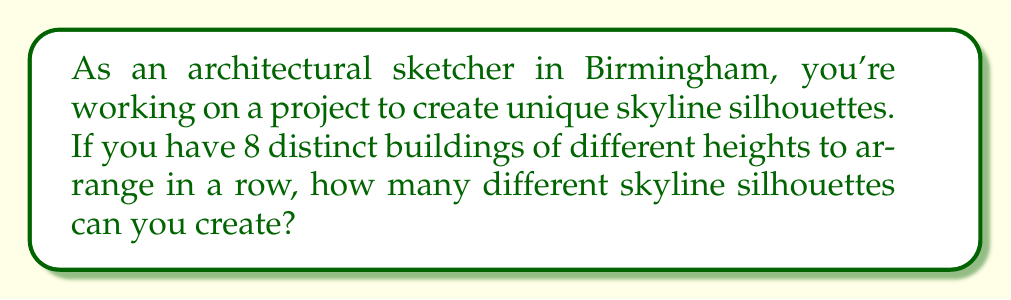Show me your answer to this math problem. Let's approach this step-by-step:

1) First, we need to understand what determines a unique skyline silhouette. The order of the buildings matters, as changing the order will create a different silhouette.

2) This problem is essentially asking about the number of permutations of 8 distinct objects.

3) In permutations, we arrange all n objects in a specific order. The formula for permutations of n distinct objects is:

   $$P(n) = n!$$

   Where $n!$ represents the factorial of n.

4) In this case, we have 8 distinct buildings, so $n = 8$.

5) Let's calculate $8!$:
   
   $$8! = 8 \times 7 \times 6 \times 5 \times 4 \times 3 \times 2 \times 1 = 40,320$$

6) Therefore, there are 40,320 different ways to arrange 8 distinct buildings, resulting in 40,320 unique skyline silhouettes.
Answer: 40,320 